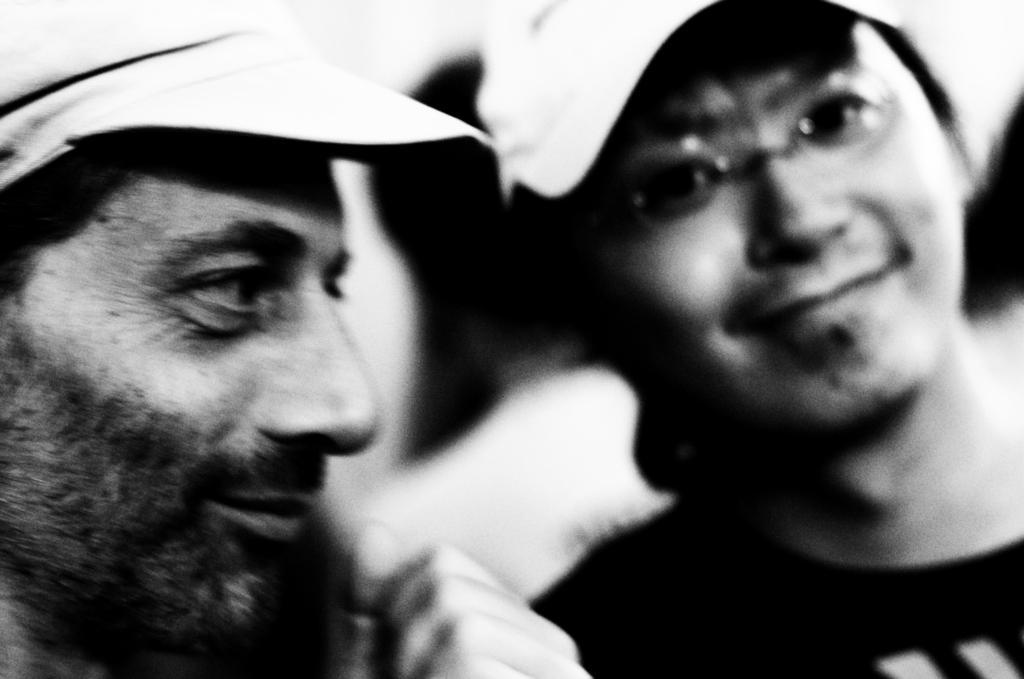Can you describe this image briefly? In the picture there are two men wearing caps. 